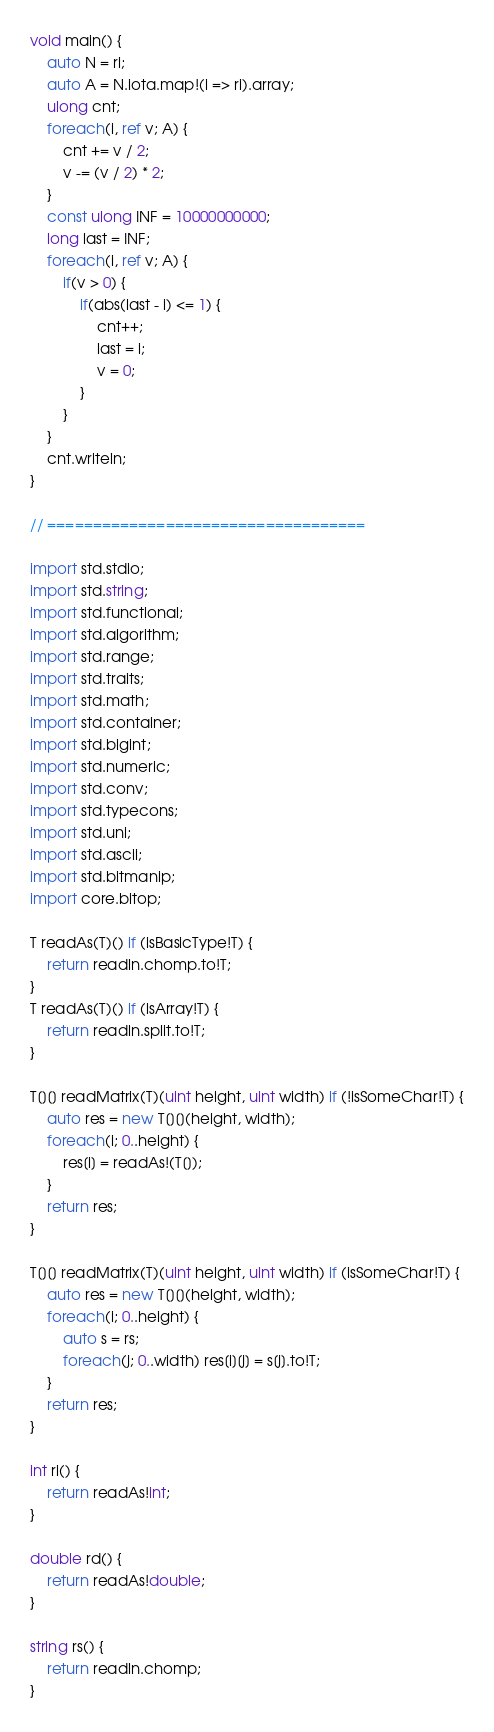<code> <loc_0><loc_0><loc_500><loc_500><_D_>void main() {
	auto N = ri;
	auto A = N.iota.map!(i => ri).array;
	ulong cnt;
	foreach(i, ref v; A) {
		cnt += v / 2;
		v -= (v / 2) * 2;
	}
	const ulong INF = 10000000000;
	long last = INF;
	foreach(i, ref v; A) {
		if(v > 0) {
			if(abs(last - i) <= 1) {
				cnt++;
				last = i;
				v = 0;
			}
		}
	}
	cnt.writeln;
}

// ===================================

import std.stdio;
import std.string;
import std.functional;
import std.algorithm;
import std.range;
import std.traits;
import std.math;
import std.container;
import std.bigint;
import std.numeric;
import std.conv;
import std.typecons;
import std.uni;
import std.ascii;
import std.bitmanip;
import core.bitop;

T readAs(T)() if (isBasicType!T) {
	return readln.chomp.to!T;
}
T readAs(T)() if (isArray!T) {
	return readln.split.to!T;
}

T[][] readMatrix(T)(uint height, uint width) if (!isSomeChar!T) {
	auto res = new T[][](height, width);
	foreach(i; 0..height) {
		res[i] = readAs!(T[]);
	}
	return res;
}

T[][] readMatrix(T)(uint height, uint width) if (isSomeChar!T) {
	auto res = new T[][](height, width);
	foreach(i; 0..height) {
		auto s = rs;
		foreach(j; 0..width) res[i][j] = s[j].to!T;
	}
	return res;
}

int ri() {
	return readAs!int;
}

double rd() {
	return readAs!double;
}

string rs() {
	return readln.chomp;
}</code> 